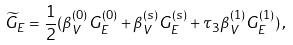<formula> <loc_0><loc_0><loc_500><loc_500>\widetilde { G } _ { E } = \frac { 1 } { 2 } ( \beta _ { V } ^ { ( 0 ) } G _ { E } ^ { ( 0 ) } + \beta _ { V } ^ { ( s ) } G _ { E } ^ { ( s ) } + \tau _ { 3 } \beta _ { V } ^ { ( 1 ) } G _ { E } ^ { ( 1 ) } ) \, ,</formula> 